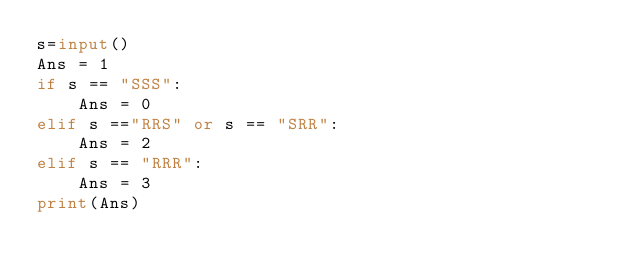<code> <loc_0><loc_0><loc_500><loc_500><_Python_>s=input()
Ans = 1
if s == "SSS":
    Ans = 0
elif s =="RRS" or s == "SRR":
    Ans = 2
elif s == "RRR":
    Ans = 3
print(Ans)</code> 